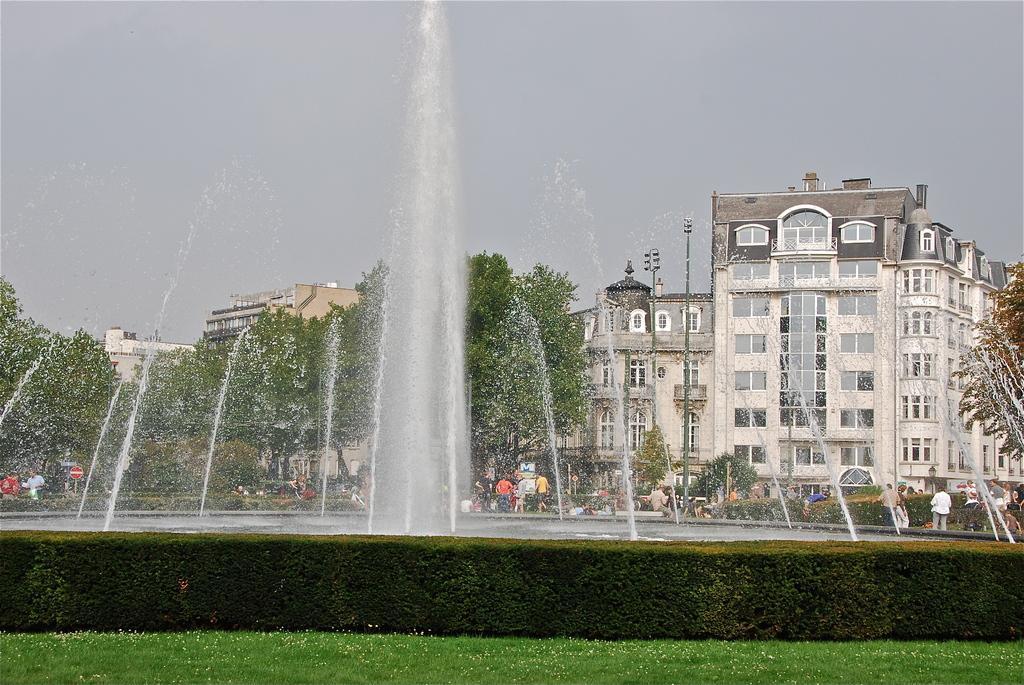Can you describe this image briefly? In this image I can see water fountain. There are bushes, trees, group of people, lights, poles and buildings. There is grass and in the background there is sky. 